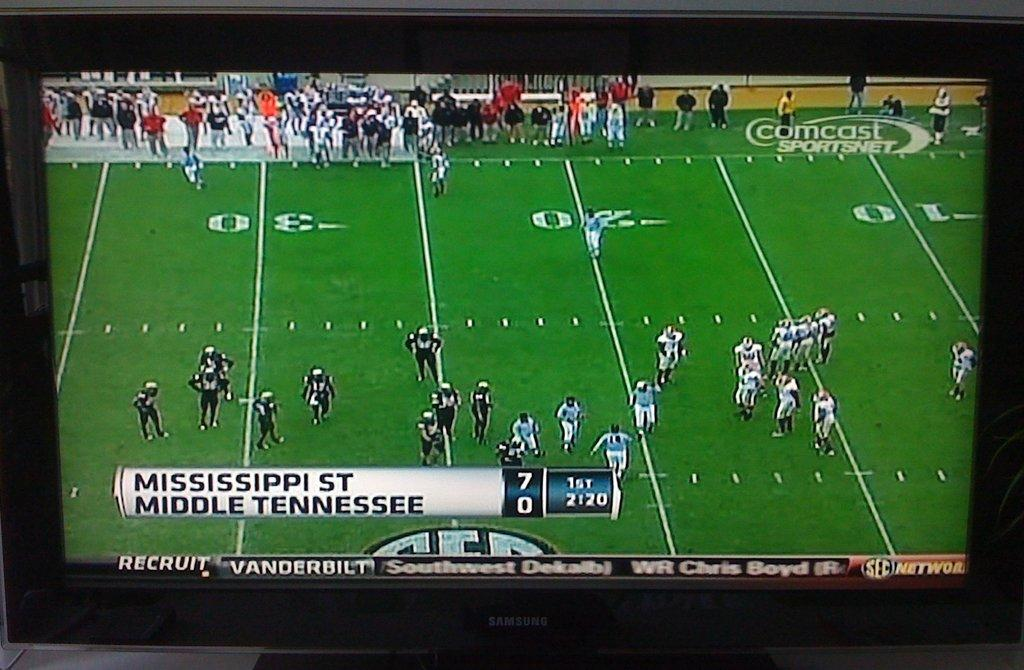<image>
Share a concise interpretation of the image provided. On a television screen Mississippi plays football against Middle Tennessee. 